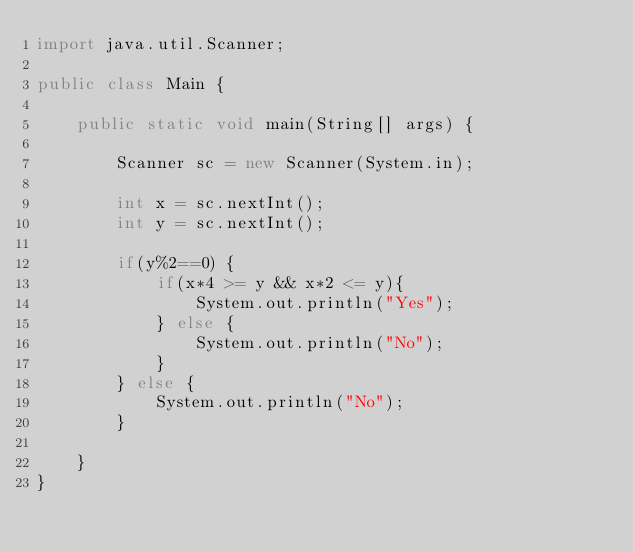Convert code to text. <code><loc_0><loc_0><loc_500><loc_500><_Java_>import java.util.Scanner;

public class Main {

	public static void main(String[] args) {

		Scanner sc = new Scanner(System.in);

		int x = sc.nextInt();
		int y = sc.nextInt();

		if(y%2==0) {
			if(x*4 >= y && x*2 <= y){
				System.out.println("Yes");
			} else {
				System.out.println("No");
			}
		} else {
			System.out.println("No");
		}

	}
}</code> 